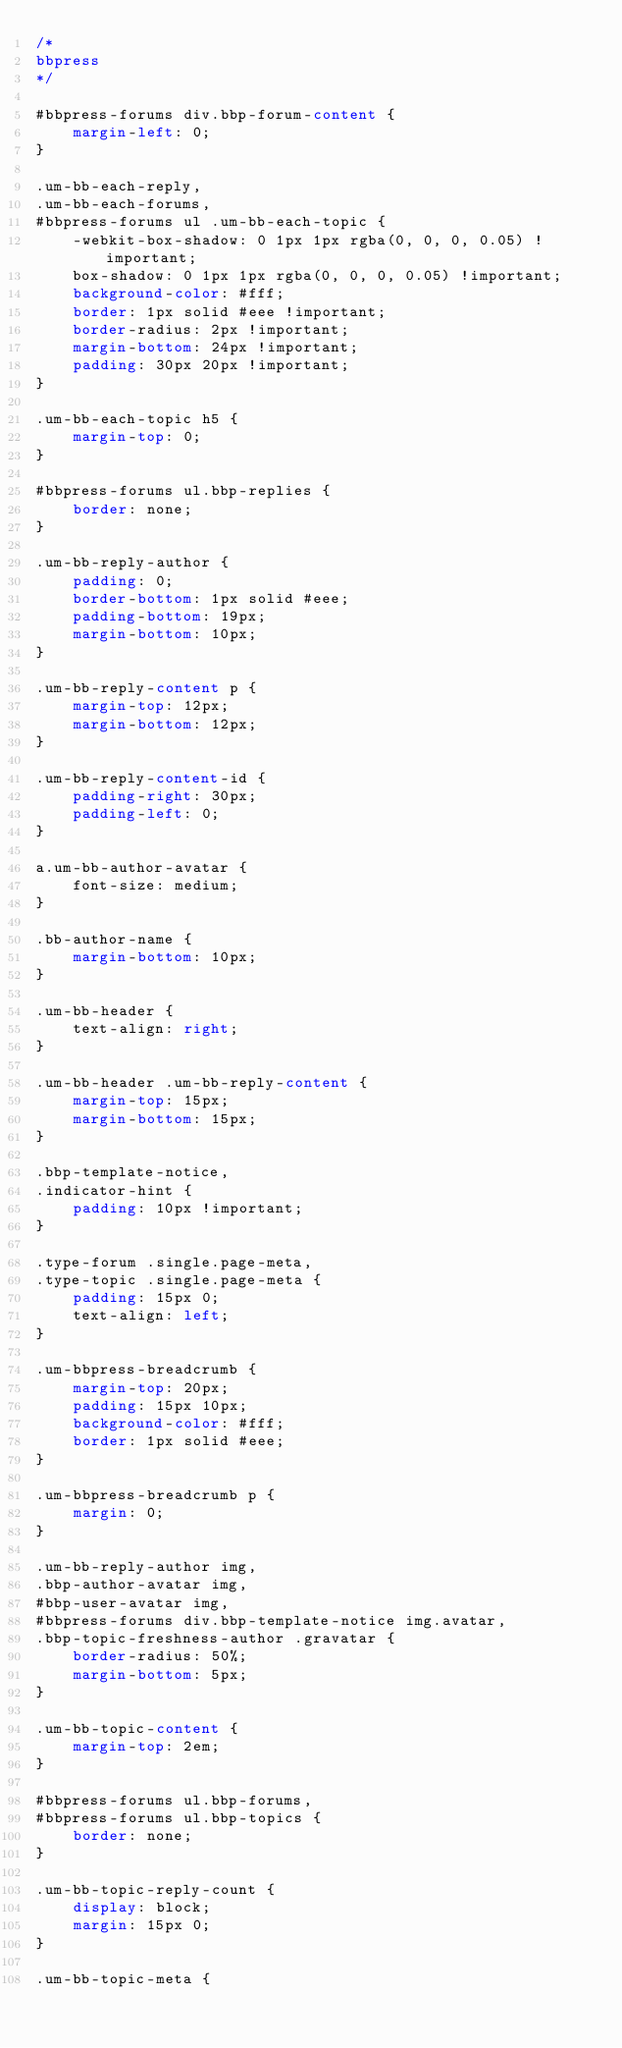<code> <loc_0><loc_0><loc_500><loc_500><_CSS_>/*
bbpress
*/

#bbpress-forums div.bbp-forum-content {
    margin-left: 0;
}

.um-bb-each-reply,
.um-bb-each-forums,
#bbpress-forums ul .um-bb-each-topic {
    -webkit-box-shadow: 0 1px 1px rgba(0, 0, 0, 0.05) !important;
    box-shadow: 0 1px 1px rgba(0, 0, 0, 0.05) !important;
    background-color: #fff;
    border: 1px solid #eee !important;
    border-radius: 2px !important;
    margin-bottom: 24px !important;
    padding: 30px 20px !important;
}

.um-bb-each-topic h5 {
    margin-top: 0;
}

#bbpress-forums ul.bbp-replies {
    border: none;
}

.um-bb-reply-author {
    padding: 0;
    border-bottom: 1px solid #eee;
    padding-bottom: 19px;
    margin-bottom: 10px;
}

.um-bb-reply-content p {
    margin-top: 12px;
    margin-bottom: 12px;
}

.um-bb-reply-content-id {
    padding-right: 30px;
    padding-left: 0;
}

a.um-bb-author-avatar {
    font-size: medium;
}

.bb-author-name {
    margin-bottom: 10px;
}

.um-bb-header {
    text-align: right;
}

.um-bb-header .um-bb-reply-content {
    margin-top: 15px;
    margin-bottom: 15px;
}

.bbp-template-notice,
.indicator-hint {
    padding: 10px !important;
}

.type-forum .single.page-meta,
.type-topic .single.page-meta {
    padding: 15px 0;
    text-align: left;
}

.um-bbpress-breadcrumb {
    margin-top: 20px;
    padding: 15px 10px;
    background-color: #fff;
    border: 1px solid #eee;
}

.um-bbpress-breadcrumb p {
    margin: 0;
}

.um-bb-reply-author img,
.bbp-author-avatar img,
#bbp-user-avatar img,
#bbpress-forums div.bbp-template-notice img.avatar,
.bbp-topic-freshness-author .gravatar {
    border-radius: 50%;
    margin-bottom: 5px;
}

.um-bb-topic-content {
    margin-top: 2em;
}

#bbpress-forums ul.bbp-forums,
#bbpress-forums ul.bbp-topics {
    border: none;
}

.um-bb-topic-reply-count {
    display: block;
    margin: 15px 0;
}

.um-bb-topic-meta {</code> 